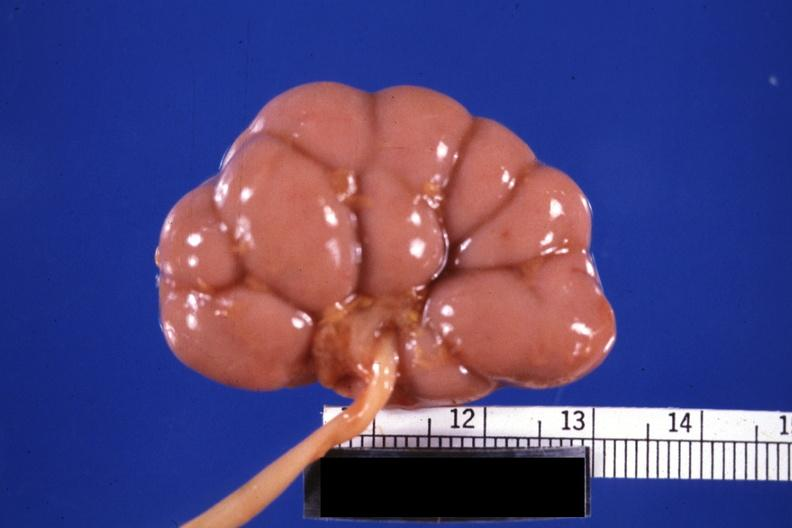what is present?
Answer the question using a single word or phrase. Fetal lobulation 